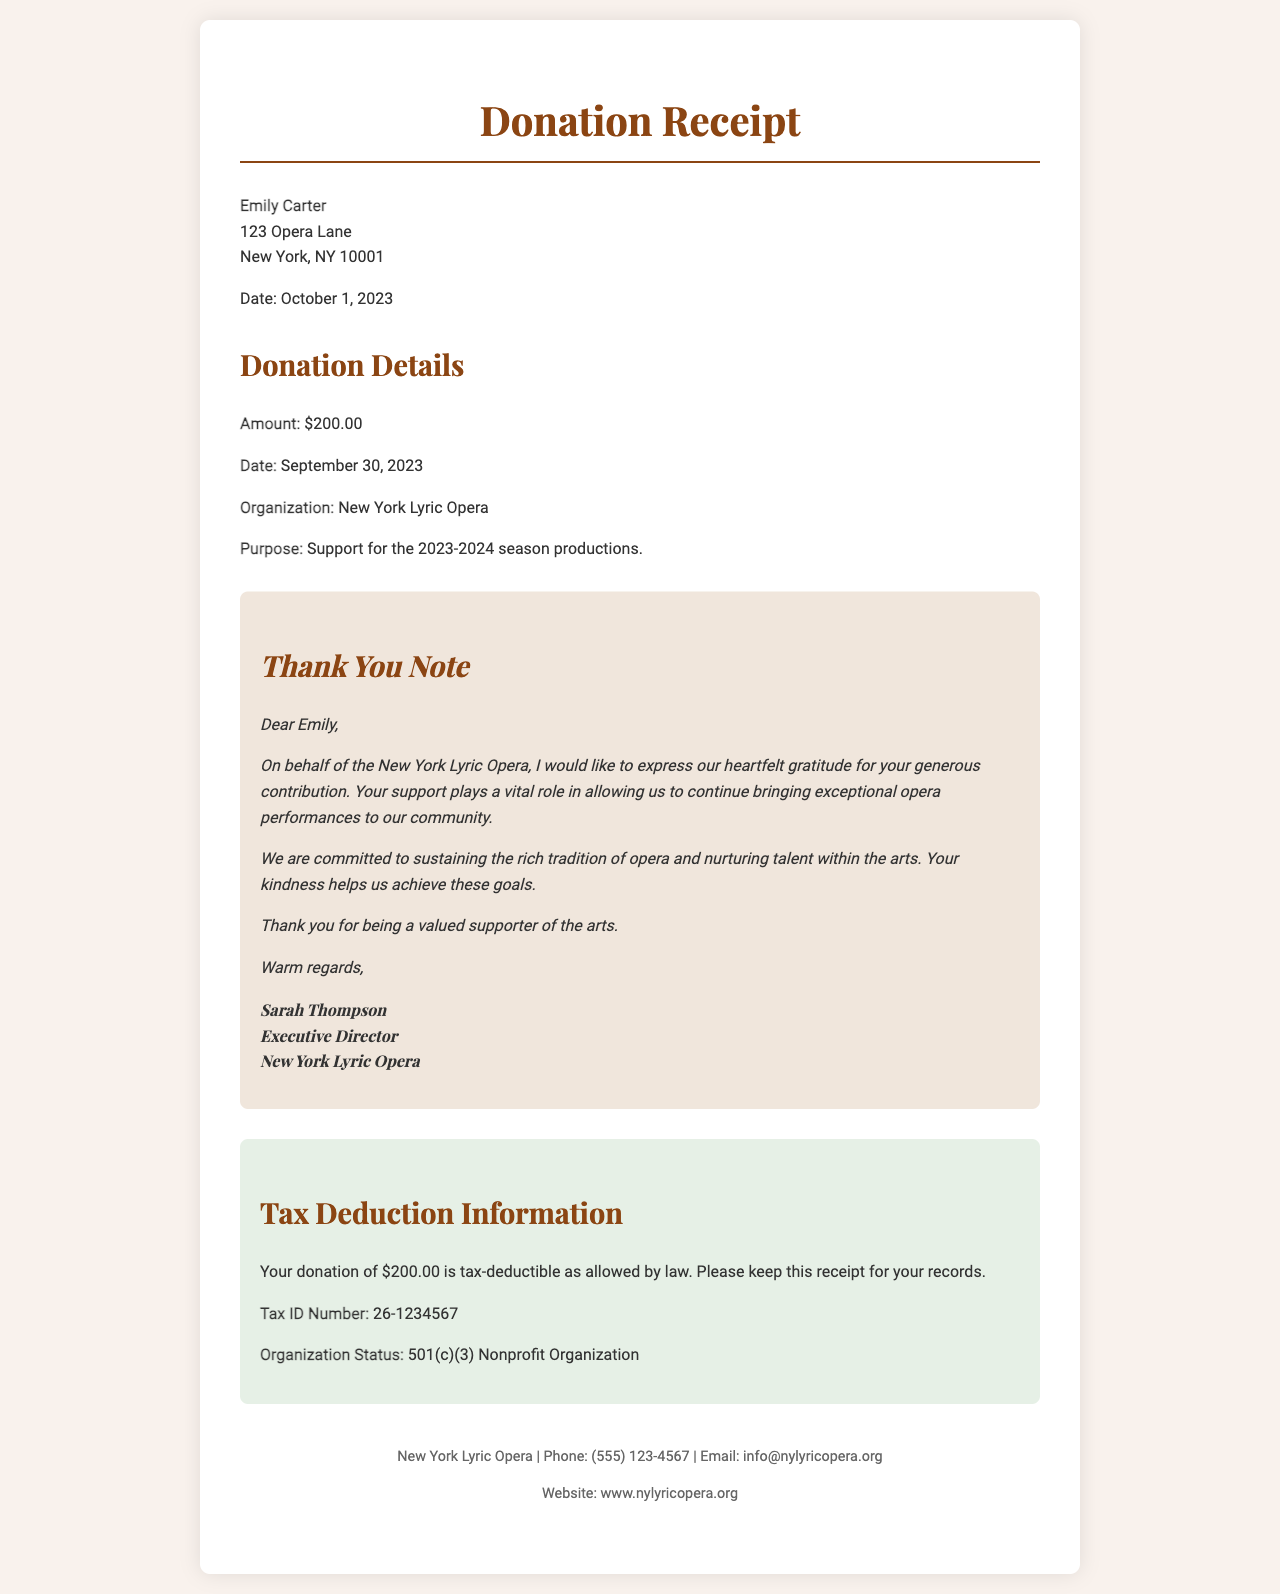what is the name of the donor? The name of the donor is mentioned at the beginning of the receipt.
Answer: Emily Carter what is the donation amount? The donation amount is specifically stated in the donation details section.
Answer: $200.00 what is the purpose of the donation? The purpose of the donation is outlined in the donation details section.
Answer: Support for the 2023-2024 season productions who signed the thank you note? The signature is included in the appreciation note section of the receipt.
Answer: Sarah Thompson what is the date of the donation? The date of the donation is detailed in the donation information portion.
Answer: September 30, 2023 what is the tax ID number of the organization? The tax ID number is provided in the tax deduction information section.
Answer: 26-1234567 what is the name of the organization? The name of the organization is stated in the donation details section.
Answer: New York Lyric Opera is the donation tax-deductible? The tax deduction information explicitly confirms the tax status of the donation.
Answer: Yes what type of organization is the New York Lyric Opera? The type of organization is explained in the tax deduction information section.
Answer: 501(c)(3) Nonprofit Organization 